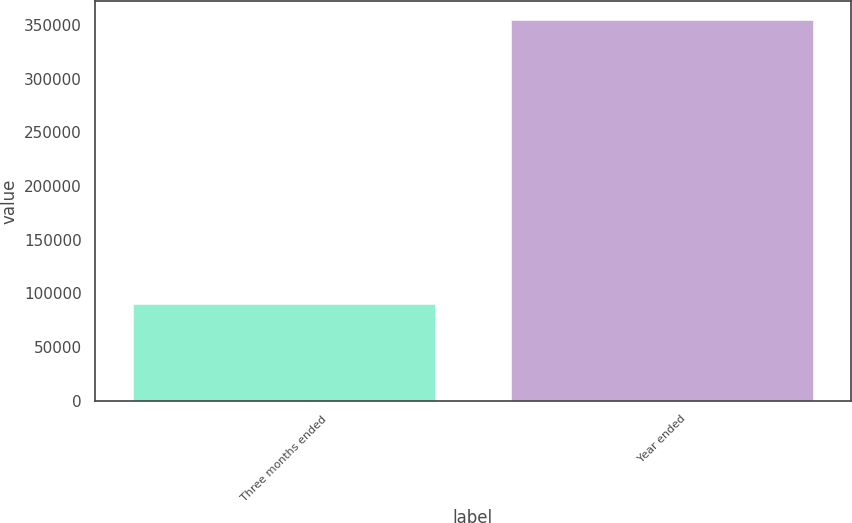<chart> <loc_0><loc_0><loc_500><loc_500><bar_chart><fcel>Three months ended<fcel>Year ended<nl><fcel>89791<fcel>354181<nl></chart> 